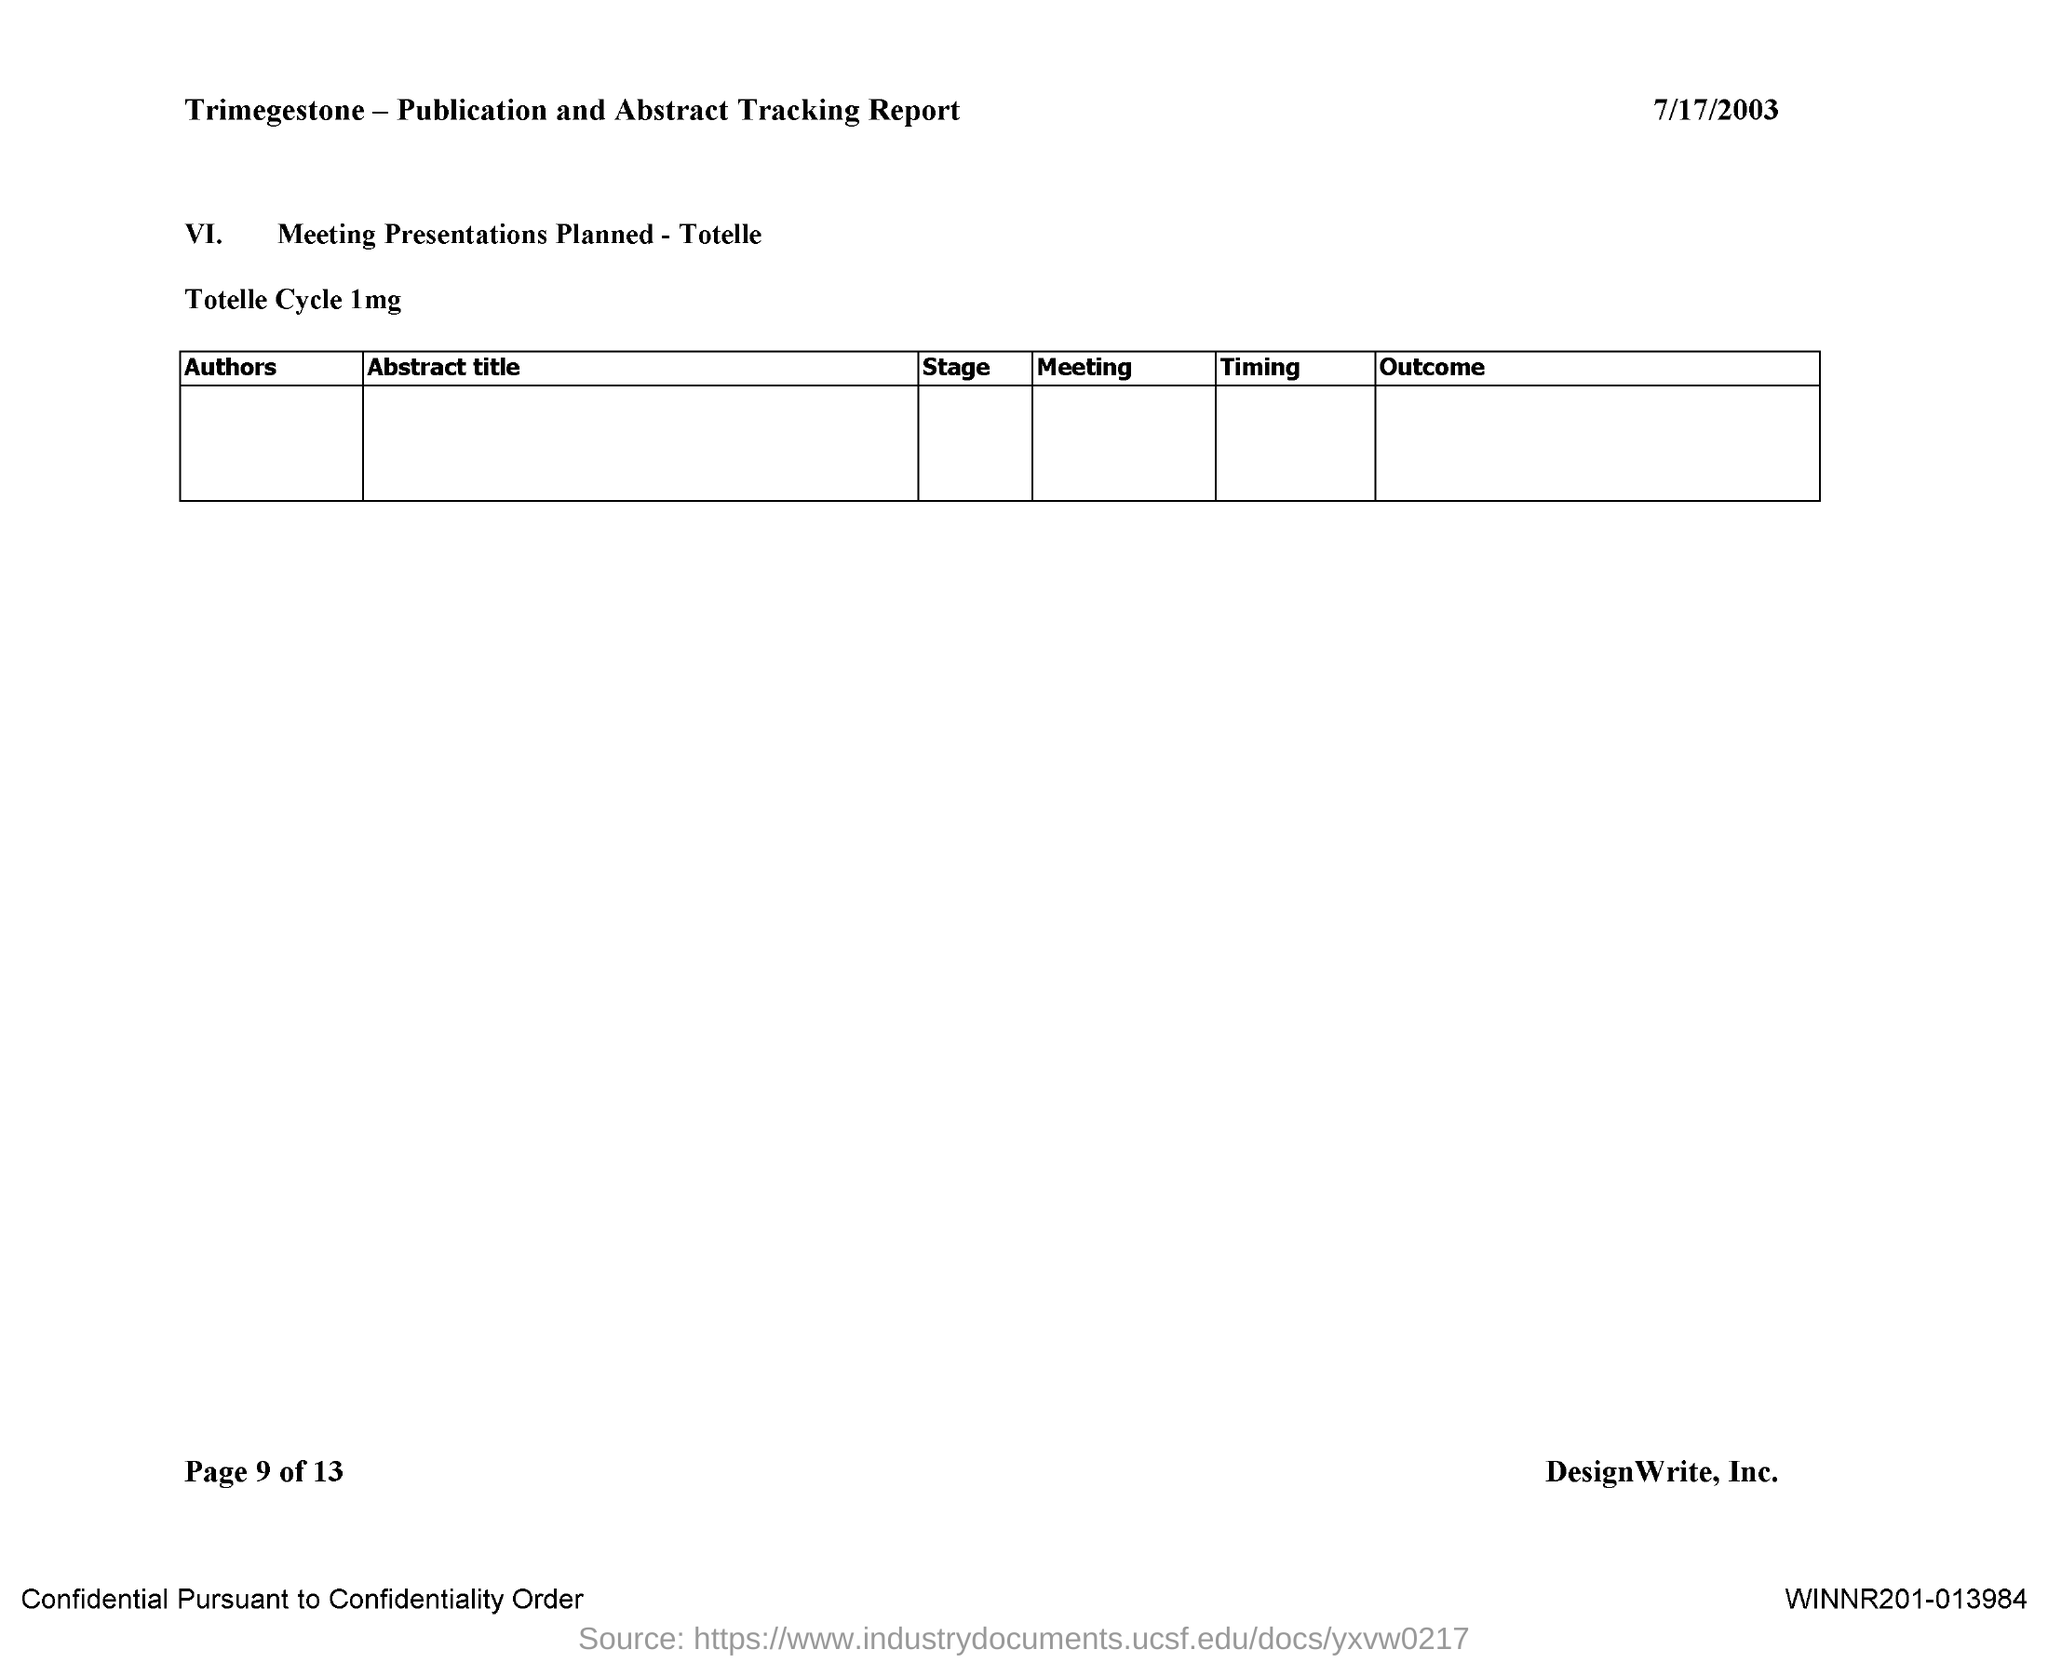What is the date on the document?
Ensure brevity in your answer.  7/17/2003. 